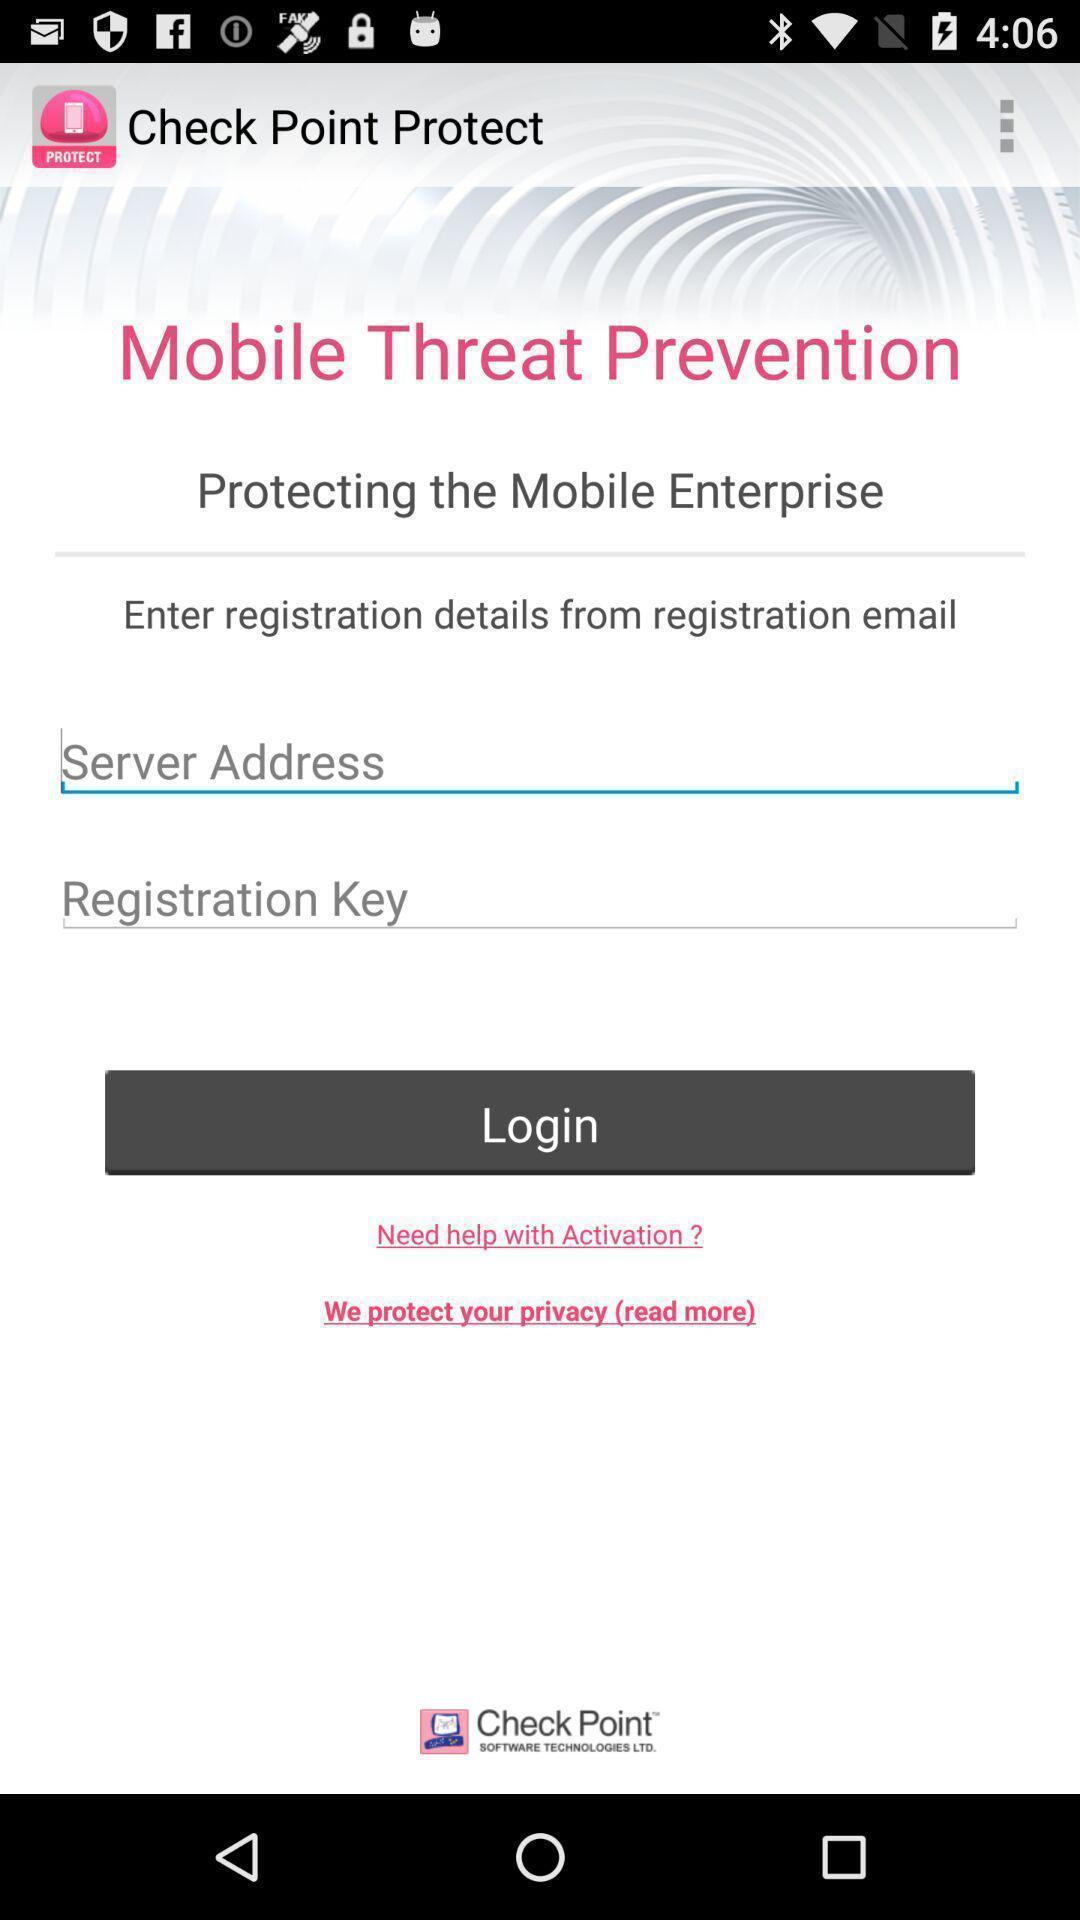Tell me what you see in this picture. Screen displaying multiple options in login page. 